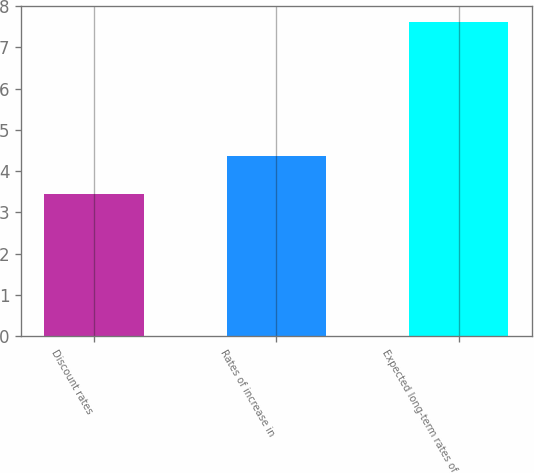<chart> <loc_0><loc_0><loc_500><loc_500><bar_chart><fcel>Discount rates<fcel>Rates of increase in<fcel>Expected long-term rates of<nl><fcel>3.45<fcel>4.36<fcel>7.62<nl></chart> 